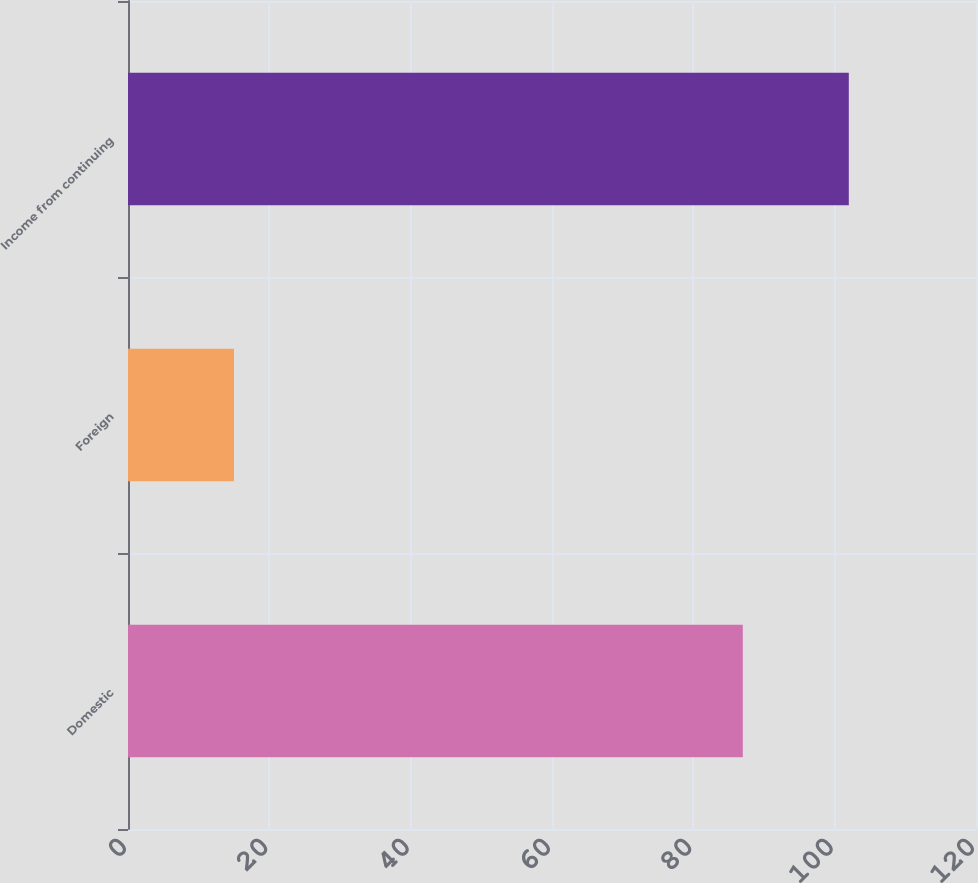Convert chart to OTSL. <chart><loc_0><loc_0><loc_500><loc_500><bar_chart><fcel>Domestic<fcel>Foreign<fcel>Income from continuing<nl><fcel>87<fcel>15<fcel>102<nl></chart> 